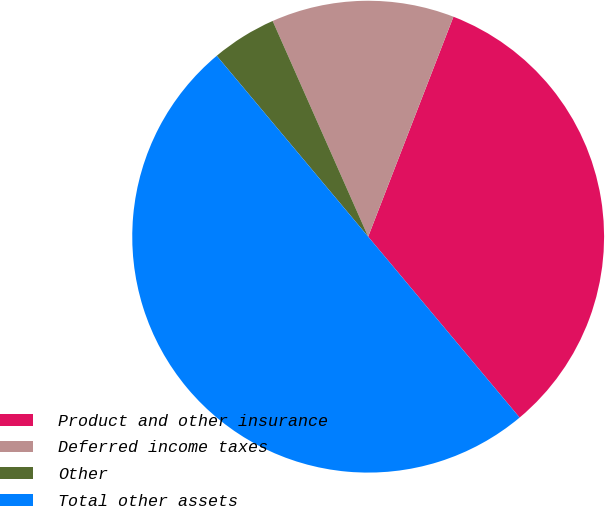Convert chart. <chart><loc_0><loc_0><loc_500><loc_500><pie_chart><fcel>Product and other insurance<fcel>Deferred income taxes<fcel>Other<fcel>Total other assets<nl><fcel>33.02%<fcel>12.52%<fcel>4.46%<fcel>50.0%<nl></chart> 